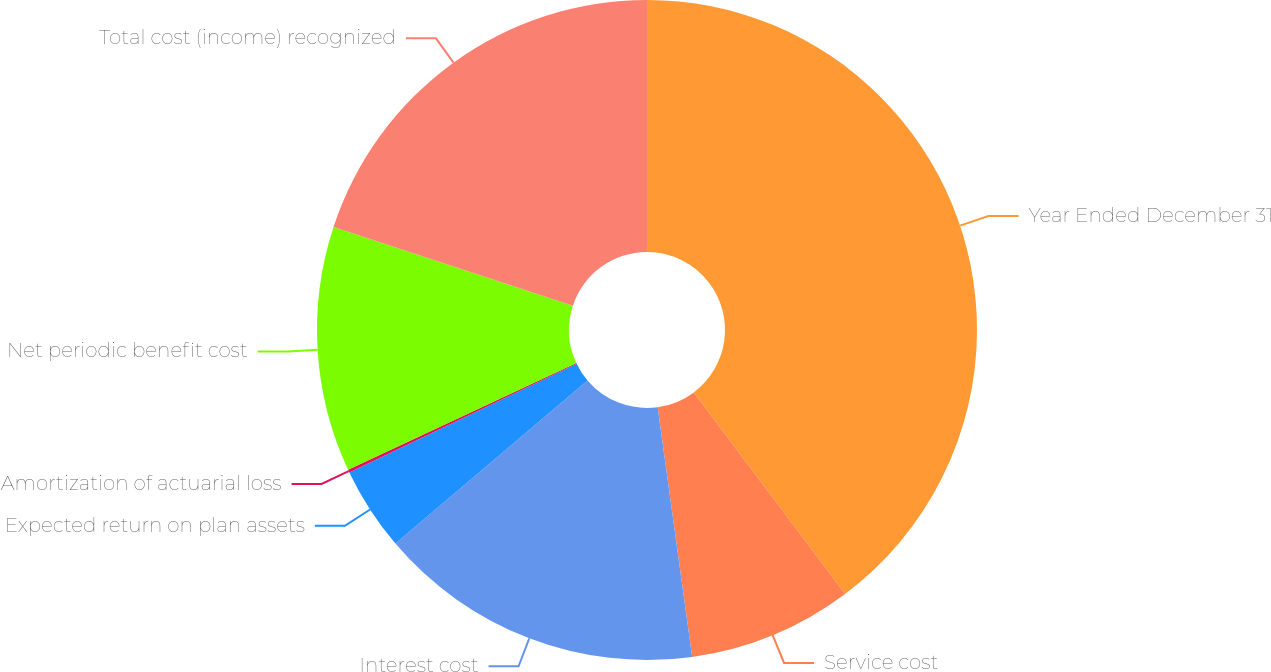Convert chart. <chart><loc_0><loc_0><loc_500><loc_500><pie_chart><fcel>Year Ended December 31<fcel>Service cost<fcel>Interest cost<fcel>Expected return on plan assets<fcel>Amortization of actuarial loss<fcel>Net periodic benefit cost<fcel>Total cost (income) recognized<nl><fcel>39.75%<fcel>8.06%<fcel>15.98%<fcel>4.1%<fcel>0.14%<fcel>12.02%<fcel>19.94%<nl></chart> 